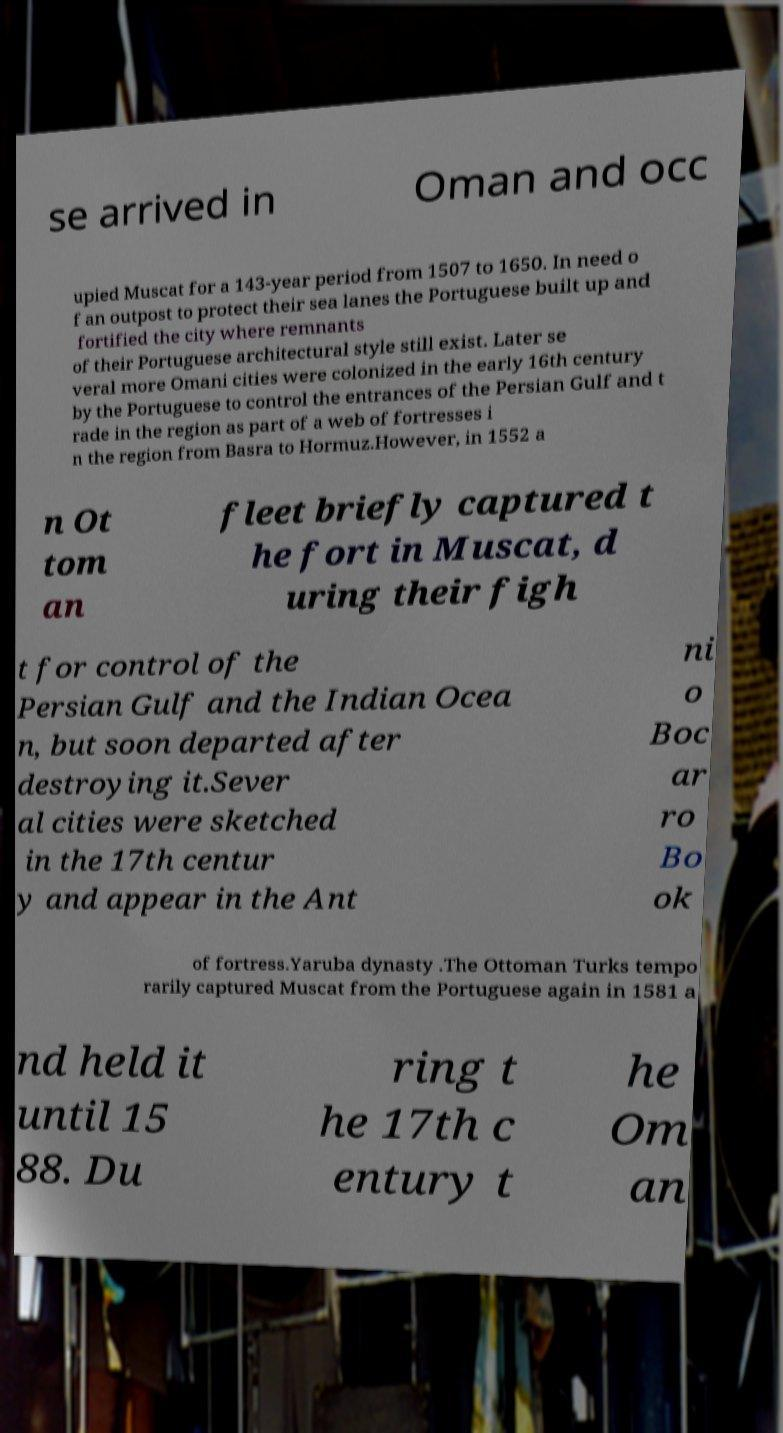What messages or text are displayed in this image? I need them in a readable, typed format. se arrived in Oman and occ upied Muscat for a 143-year period from 1507 to 1650. In need o f an outpost to protect their sea lanes the Portuguese built up and fortified the city where remnants of their Portuguese architectural style still exist. Later se veral more Omani cities were colonized in the early 16th century by the Portuguese to control the entrances of the Persian Gulf and t rade in the region as part of a web of fortresses i n the region from Basra to Hormuz.However, in 1552 a n Ot tom an fleet briefly captured t he fort in Muscat, d uring their figh t for control of the Persian Gulf and the Indian Ocea n, but soon departed after destroying it.Sever al cities were sketched in the 17th centur y and appear in the Ant ni o Boc ar ro Bo ok of fortress.Yaruba dynasty .The Ottoman Turks tempo rarily captured Muscat from the Portuguese again in 1581 a nd held it until 15 88. Du ring t he 17th c entury t he Om an 